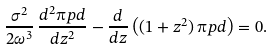<formula> <loc_0><loc_0><loc_500><loc_500>\frac { \sigma ^ { 2 } } { 2 \omega ^ { 3 } } \, \frac { d ^ { 2 } \i p d } { d z ^ { 2 } } - \frac { d } { d z } \left ( ( 1 + z ^ { 2 } ) \, \i p d \right ) = 0 .</formula> 